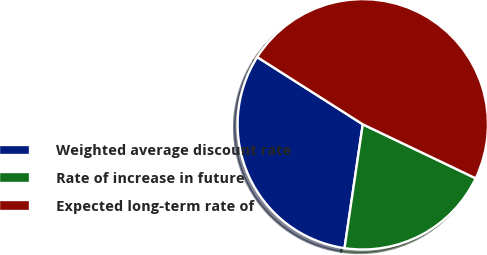Convert chart to OTSL. <chart><loc_0><loc_0><loc_500><loc_500><pie_chart><fcel>Weighted average discount rate<fcel>Rate of increase in future<fcel>Expected long-term rate of<nl><fcel>31.7%<fcel>20.23%<fcel>48.07%<nl></chart> 